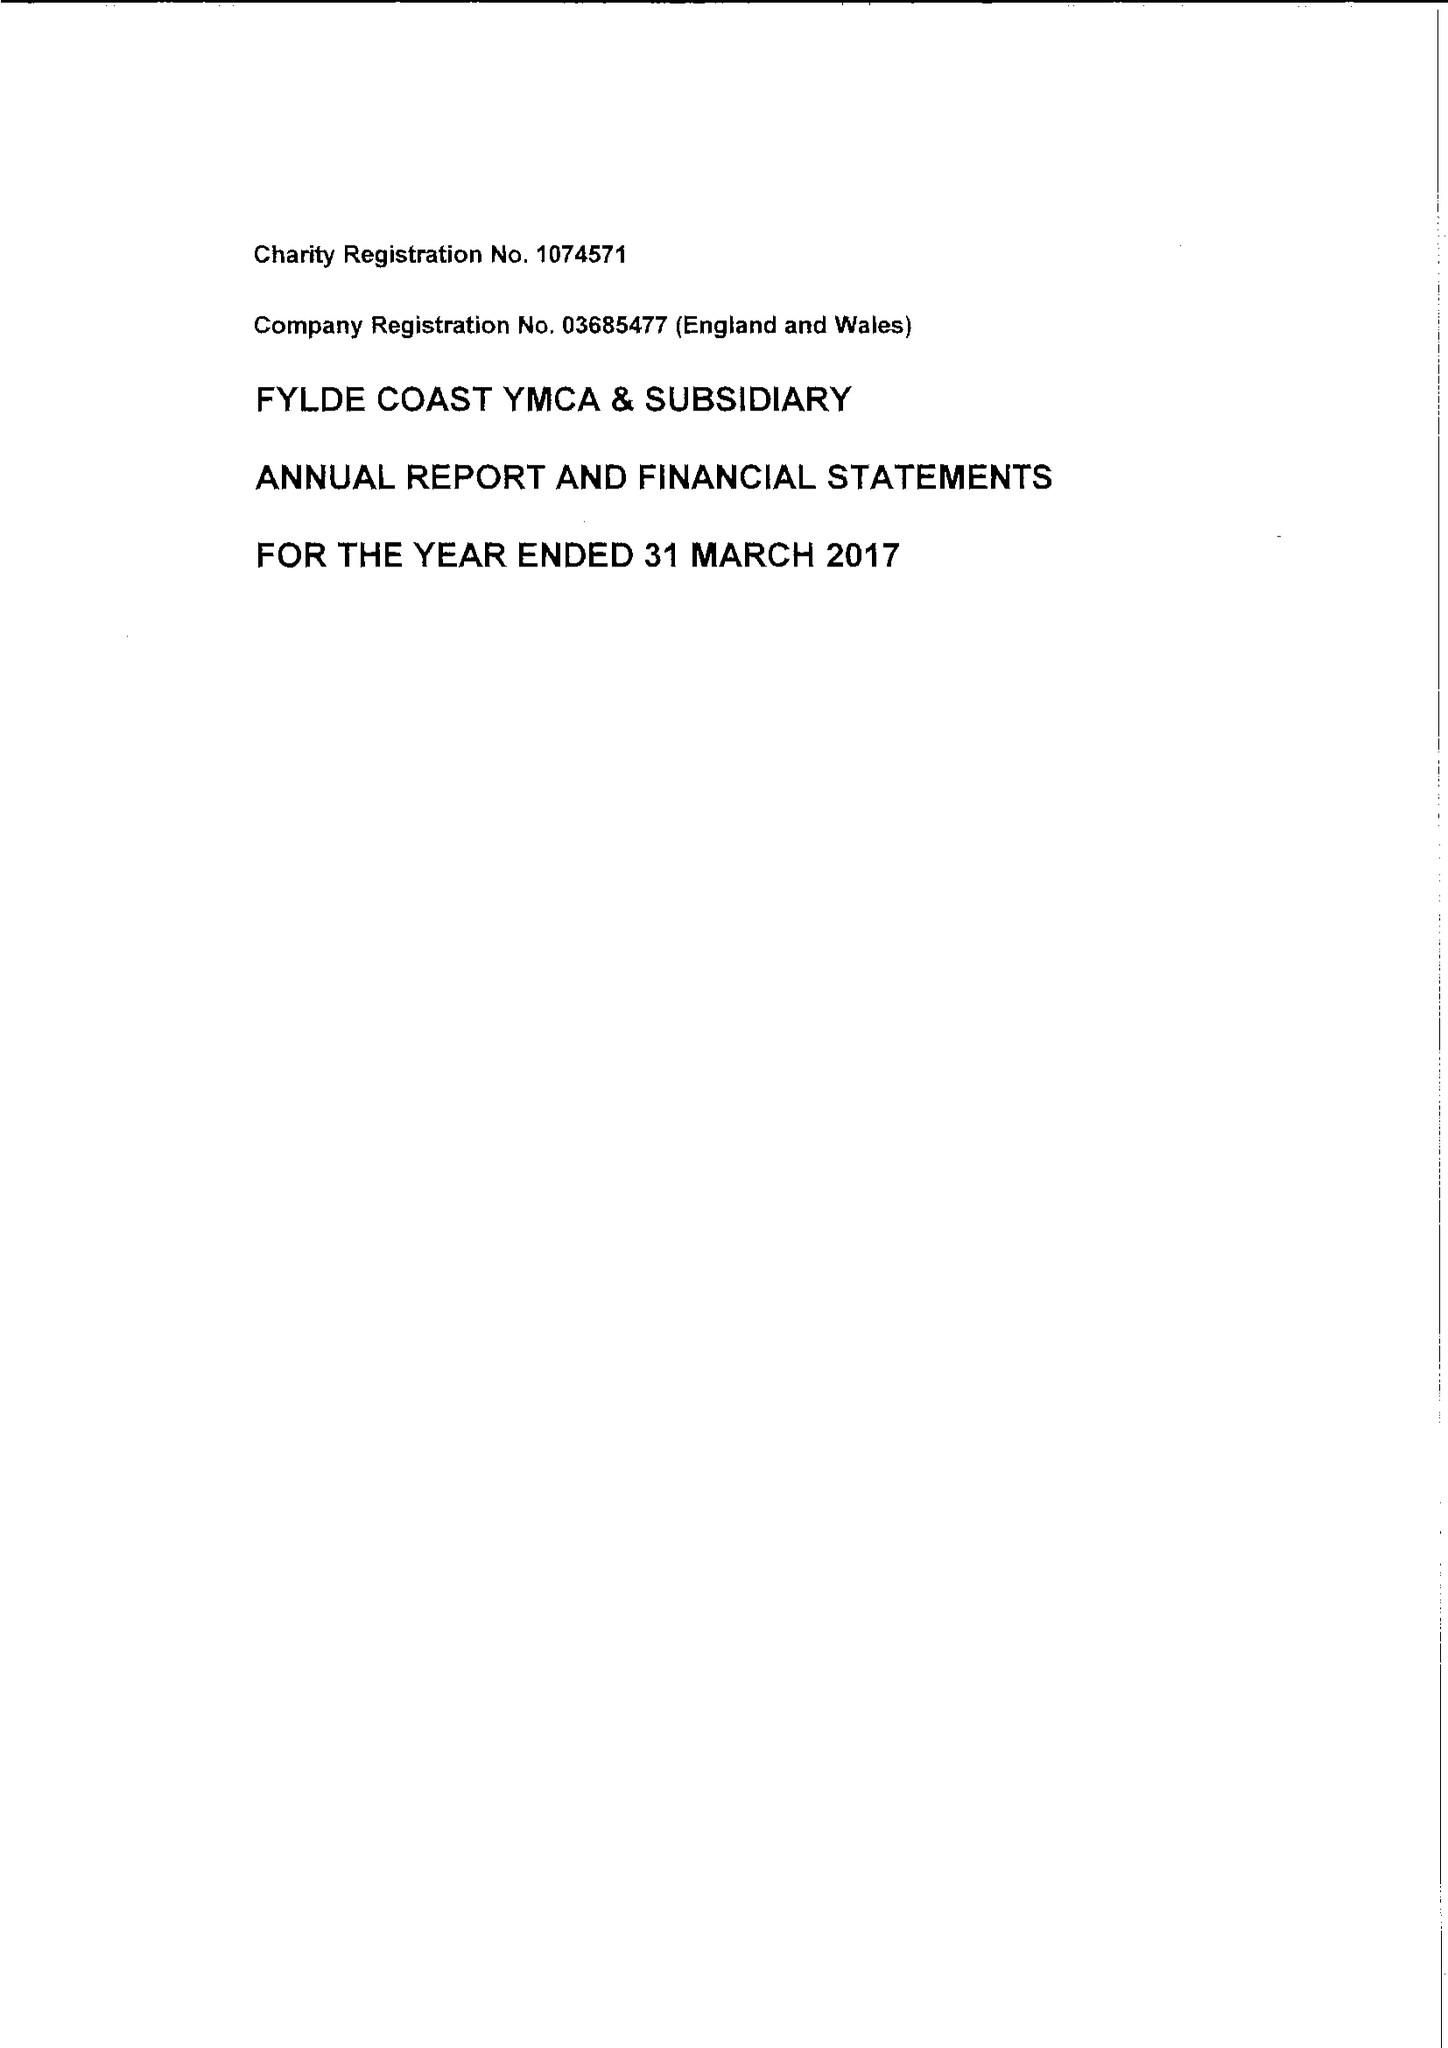What is the value for the spending_annually_in_british_pounds?
Answer the question using a single word or phrase. 8961385.00 